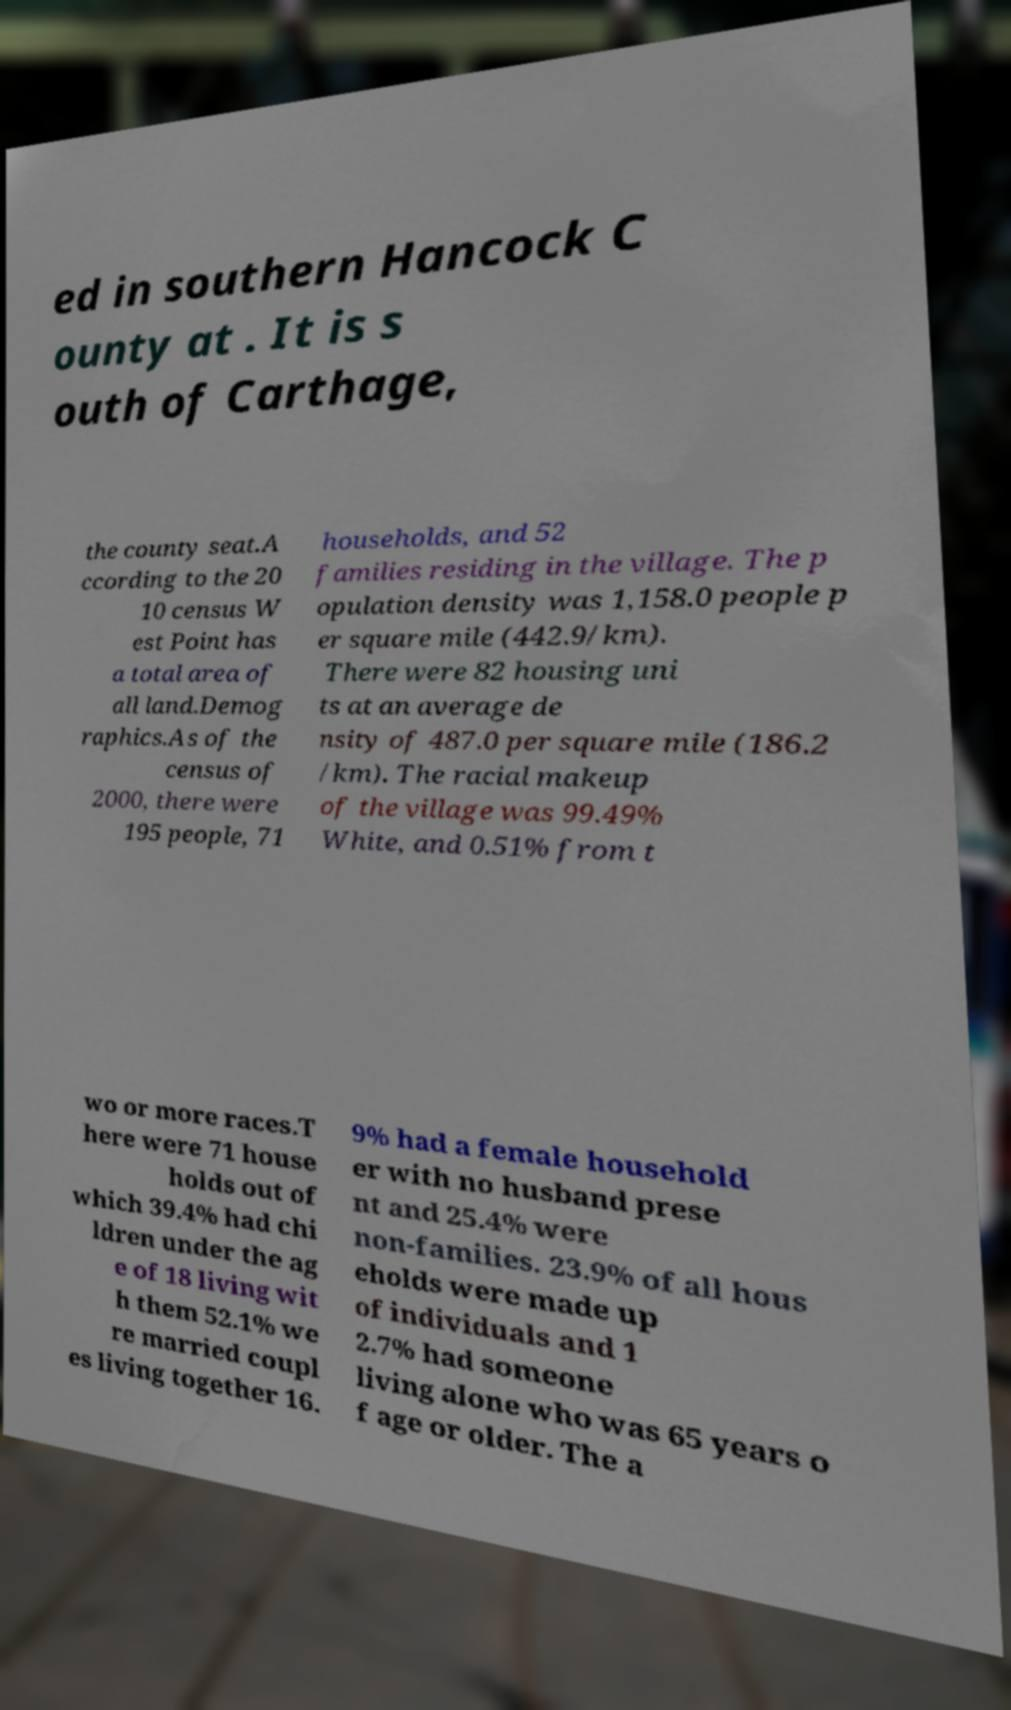What messages or text are displayed in this image? I need them in a readable, typed format. ed in southern Hancock C ounty at . It is s outh of Carthage, the county seat.A ccording to the 20 10 census W est Point has a total area of all land.Demog raphics.As of the census of 2000, there were 195 people, 71 households, and 52 families residing in the village. The p opulation density was 1,158.0 people p er square mile (442.9/km). There were 82 housing uni ts at an average de nsity of 487.0 per square mile (186.2 /km). The racial makeup of the village was 99.49% White, and 0.51% from t wo or more races.T here were 71 house holds out of which 39.4% had chi ldren under the ag e of 18 living wit h them 52.1% we re married coupl es living together 16. 9% had a female household er with no husband prese nt and 25.4% were non-families. 23.9% of all hous eholds were made up of individuals and 1 2.7% had someone living alone who was 65 years o f age or older. The a 